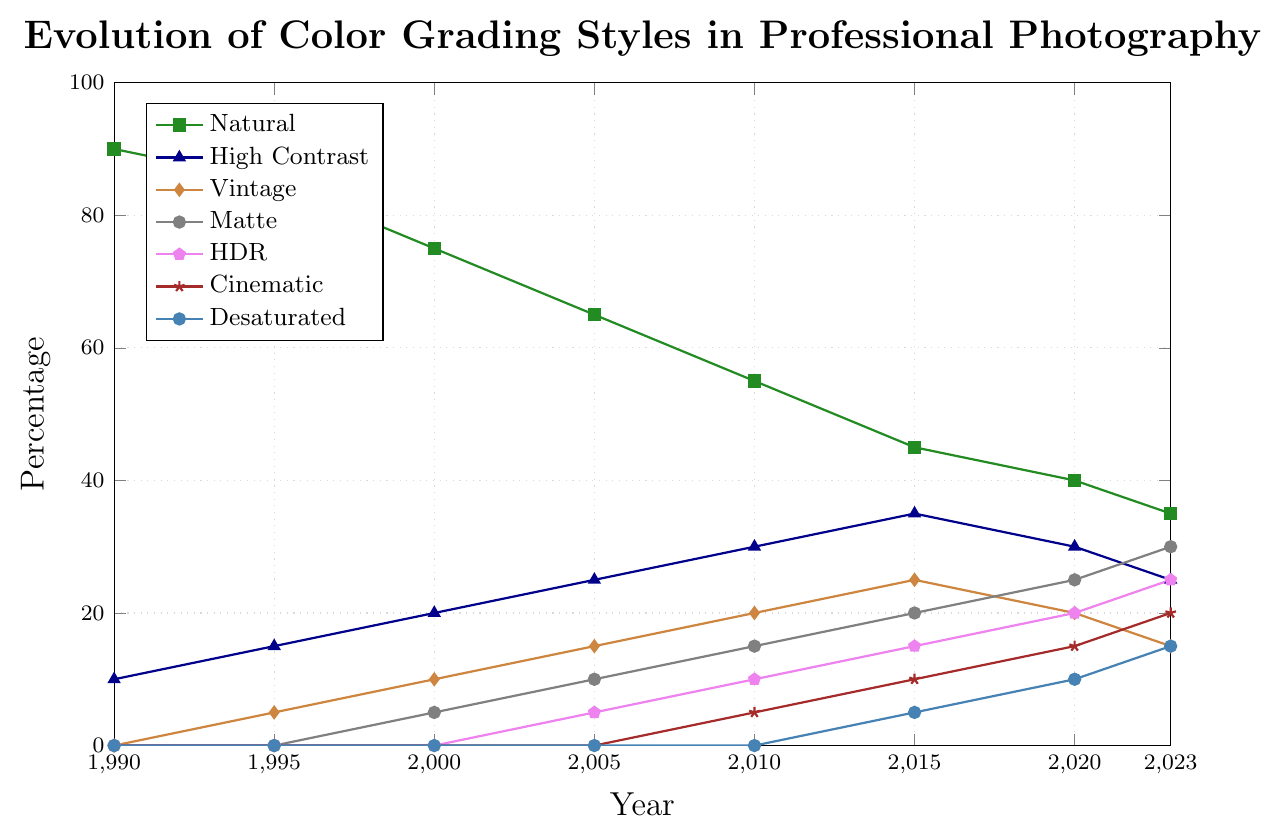What's the general trend of the 'Natural' color grading style from 1990 to 2023? The percentage of 'Natural' style decreases steadily over the years. In 1990, it starts at 90%, and by 2023, it has dropped to 35%. This shows a continuous decline.
Answer: Decreasing Which color grading style has shown the most significant growth from 1990 to 2023? The 'Matte' style has shown the most significant growth. Starting at 0% in 1990, it rises steadily to 30% by 2023.
Answer: Matte In which year do the 'HDR' and 'Desaturated' styles first appear in the chart? The 'HDR' style first appears in 2005 at 5%, and the 'Desaturated' style first appears in 2015 at 5%.
Answer: 2005 for HDR, 2015 for Desaturated Between which two consecutive years does 'Matte' style show the highest increase in percentage? The biggest increase for 'Matte' style is between 2015 and 2020, where it jumps from 20% to 25%, an increase of 5 percentage points.
Answer: Between 2015 and 2020 Compare the 'High Contrast' style percentage between the years 2000 and 2020. In 2000, the 'High Contrast' style is at 20%, and by 2020, it slightly decreases to 30%.
Answer: Higher in 2020 What is the highest percentage reached by the 'Vintage' style and in which year does it occur? The 'Vintage' style reaches its highest percentage of 25% in the year 2015.
Answer: 25% in 2015 Which two styles show equal percentages in the year 2015? In 2015, the 'Natural' style and 'High Contrast' style both show percentages of 35%.
Answer: Natural and High Contrast What is the combined percentage of 'Cinematic' and 'HDR' styles in the year 2023? In 2023, 'Cinematic' is at 20% and 'HDR' is at 25%. The combined percentage is 20% + 25% = 45%.
Answer: 45% How does the percentage of the 'Natural' style in 2010 compare to the 'Matte' style in 2023? The 'Natural' style in 2010 is at 55%, whereas the 'Matte' style in 2023 is at 30%.
Answer: Higher in 2010 What is the rate of increase for the 'Desaturated' style from 2015 to 2020? The 'Desaturated' style increases from 5% in 2015 to 10% in 2020. The rate of increase is (10-5)/5 years = 1% per year.
Answer: 1% per year 